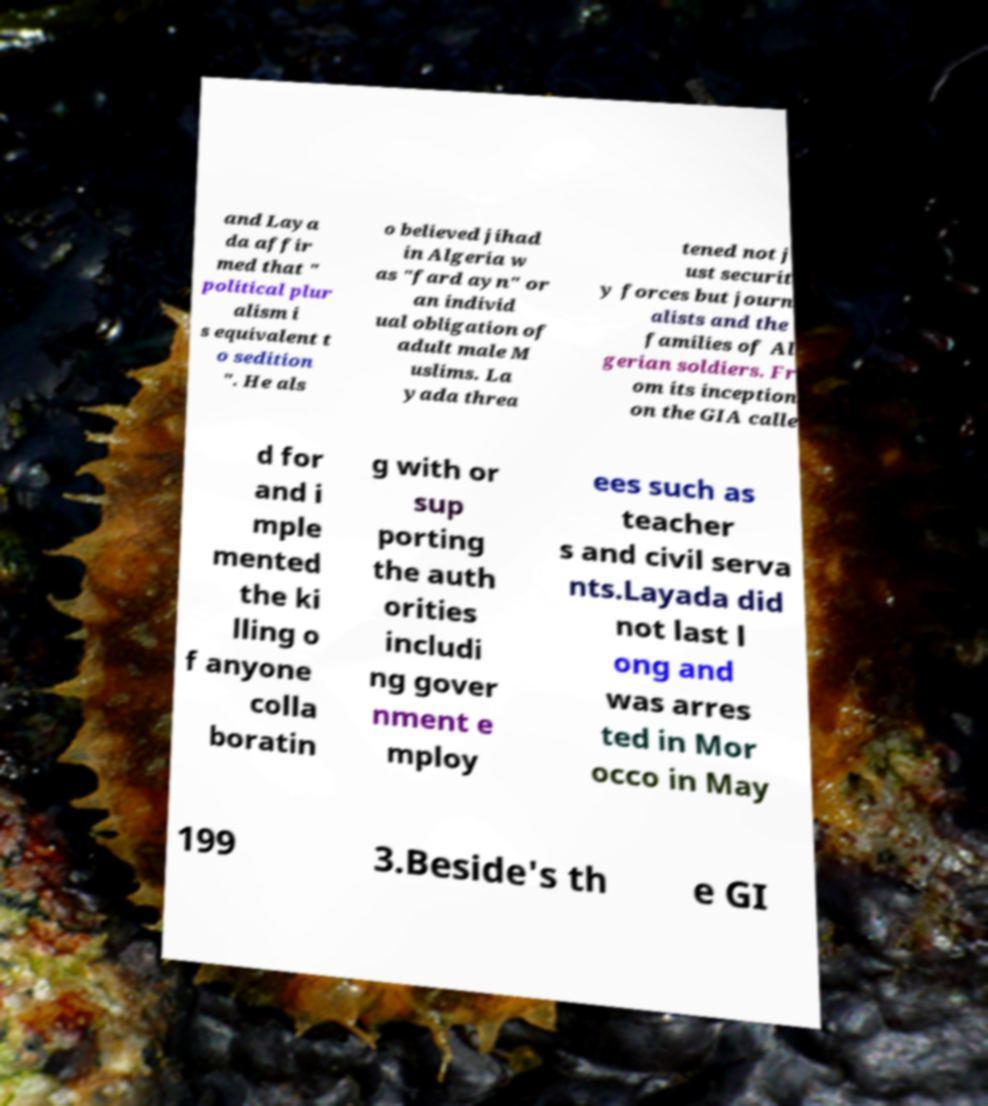For documentation purposes, I need the text within this image transcribed. Could you provide that? and Laya da affir med that " political plur alism i s equivalent t o sedition ". He als o believed jihad in Algeria w as "fard ayn" or an individ ual obligation of adult male M uslims. La yada threa tened not j ust securit y forces but journ alists and the families of Al gerian soldiers. Fr om its inception on the GIA calle d for and i mple mented the ki lling o f anyone colla boratin g with or sup porting the auth orities includi ng gover nment e mploy ees such as teacher s and civil serva nts.Layada did not last l ong and was arres ted in Mor occo in May 199 3.Beside's th e GI 